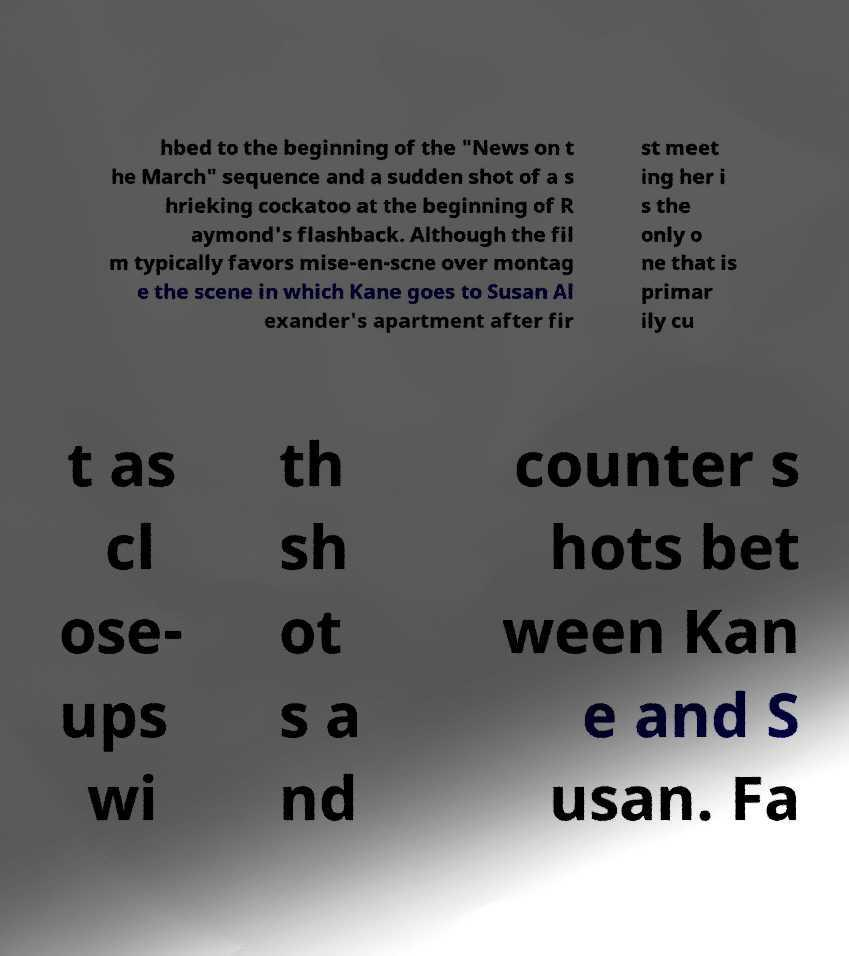Can you read and provide the text displayed in the image?This photo seems to have some interesting text. Can you extract and type it out for me? hbed to the beginning of the "News on t he March" sequence and a sudden shot of a s hrieking cockatoo at the beginning of R aymond's flashback. Although the fil m typically favors mise-en-scne over montag e the scene in which Kane goes to Susan Al exander's apartment after fir st meet ing her i s the only o ne that is primar ily cu t as cl ose- ups wi th sh ot s a nd counter s hots bet ween Kan e and S usan. Fa 